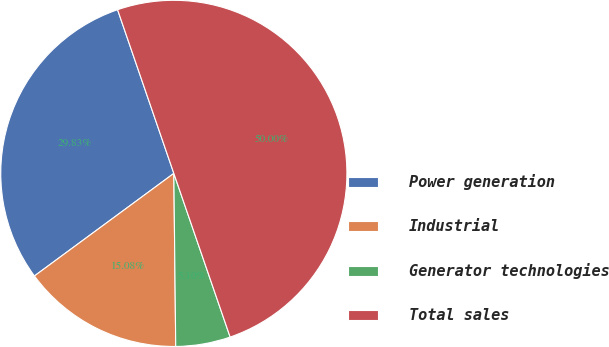Convert chart. <chart><loc_0><loc_0><loc_500><loc_500><pie_chart><fcel>Power generation<fcel>Industrial<fcel>Generator technologies<fcel>Total sales<nl><fcel>29.83%<fcel>15.08%<fcel>5.1%<fcel>50.0%<nl></chart> 